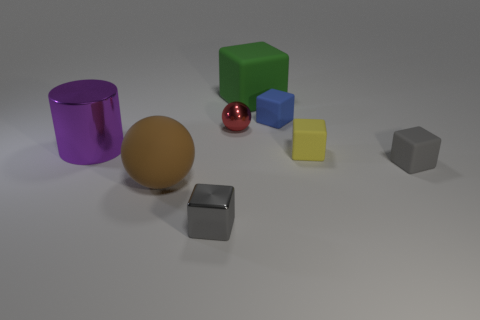Subtract 2 cubes. How many cubes are left? 3 Subtract all blue cubes. How many cubes are left? 4 Subtract all yellow balls. How many gray cubes are left? 2 Subtract all small yellow blocks. How many blocks are left? 4 Add 2 tiny yellow cubes. How many objects exist? 10 Subtract all cyan blocks. Subtract all green spheres. How many blocks are left? 5 Subtract 0 green balls. How many objects are left? 8 Subtract all cylinders. How many objects are left? 7 Subtract all small cyan rubber blocks. Subtract all blue rubber cubes. How many objects are left? 7 Add 4 blue rubber objects. How many blue rubber objects are left? 5 